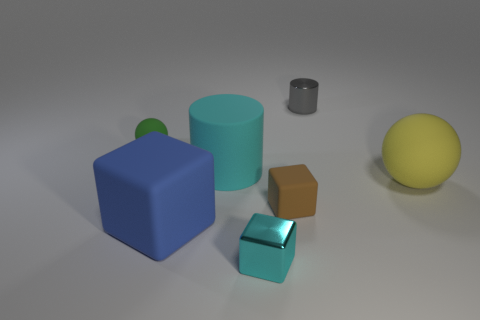How many objects are large cyan objects or things in front of the tiny gray cylinder?
Ensure brevity in your answer.  6. What number of other objects are the same size as the green thing?
Offer a very short reply. 3. Do the ball to the left of the brown rubber object and the thing behind the green rubber ball have the same material?
Offer a terse response. No. How many big matte cylinders are to the left of the green matte ball?
Ensure brevity in your answer.  0. How many purple objects are tiny matte spheres or small blocks?
Your response must be concise. 0. There is a cyan thing that is the same size as the gray cylinder; what is it made of?
Make the answer very short. Metal. The small object that is behind the metallic cube and in front of the tiny green thing has what shape?
Provide a short and direct response. Cube. The sphere that is the same size as the blue cube is what color?
Make the answer very short. Yellow. Is the size of the metal thing behind the large yellow sphere the same as the shiny thing that is in front of the cyan cylinder?
Offer a terse response. Yes. What is the size of the cyan thing that is behind the cube that is left of the cyan object that is behind the large yellow object?
Provide a succinct answer. Large. 